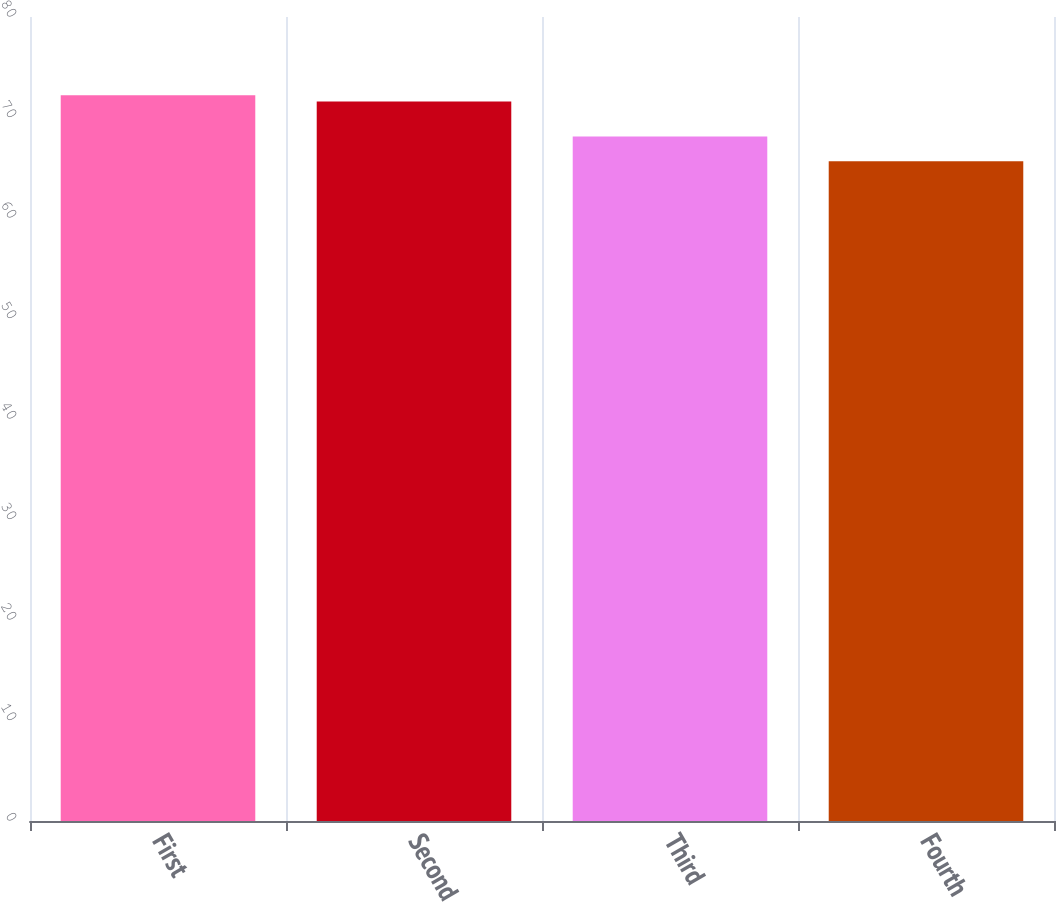Convert chart. <chart><loc_0><loc_0><loc_500><loc_500><bar_chart><fcel>First<fcel>Second<fcel>Third<fcel>Fourth<nl><fcel>72.21<fcel>71.58<fcel>68.1<fcel>65.65<nl></chart> 